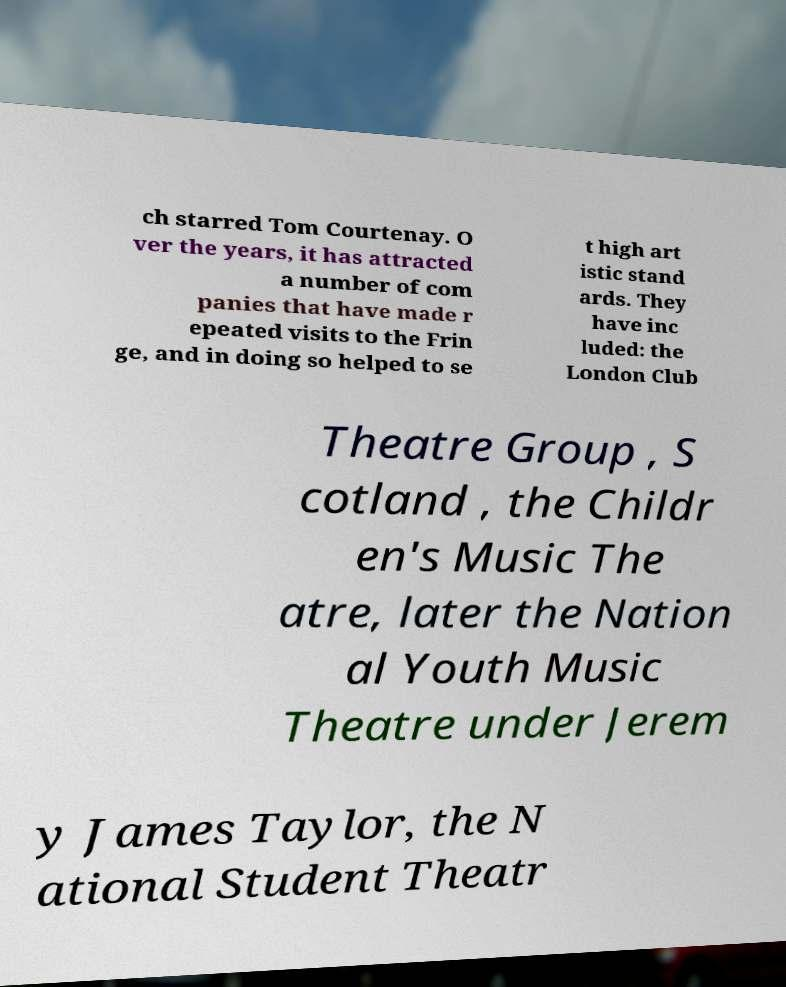There's text embedded in this image that I need extracted. Can you transcribe it verbatim? ch starred Tom Courtenay. O ver the years, it has attracted a number of com panies that have made r epeated visits to the Frin ge, and in doing so helped to se t high art istic stand ards. They have inc luded: the London Club Theatre Group , S cotland , the Childr en's Music The atre, later the Nation al Youth Music Theatre under Jerem y James Taylor, the N ational Student Theatr 